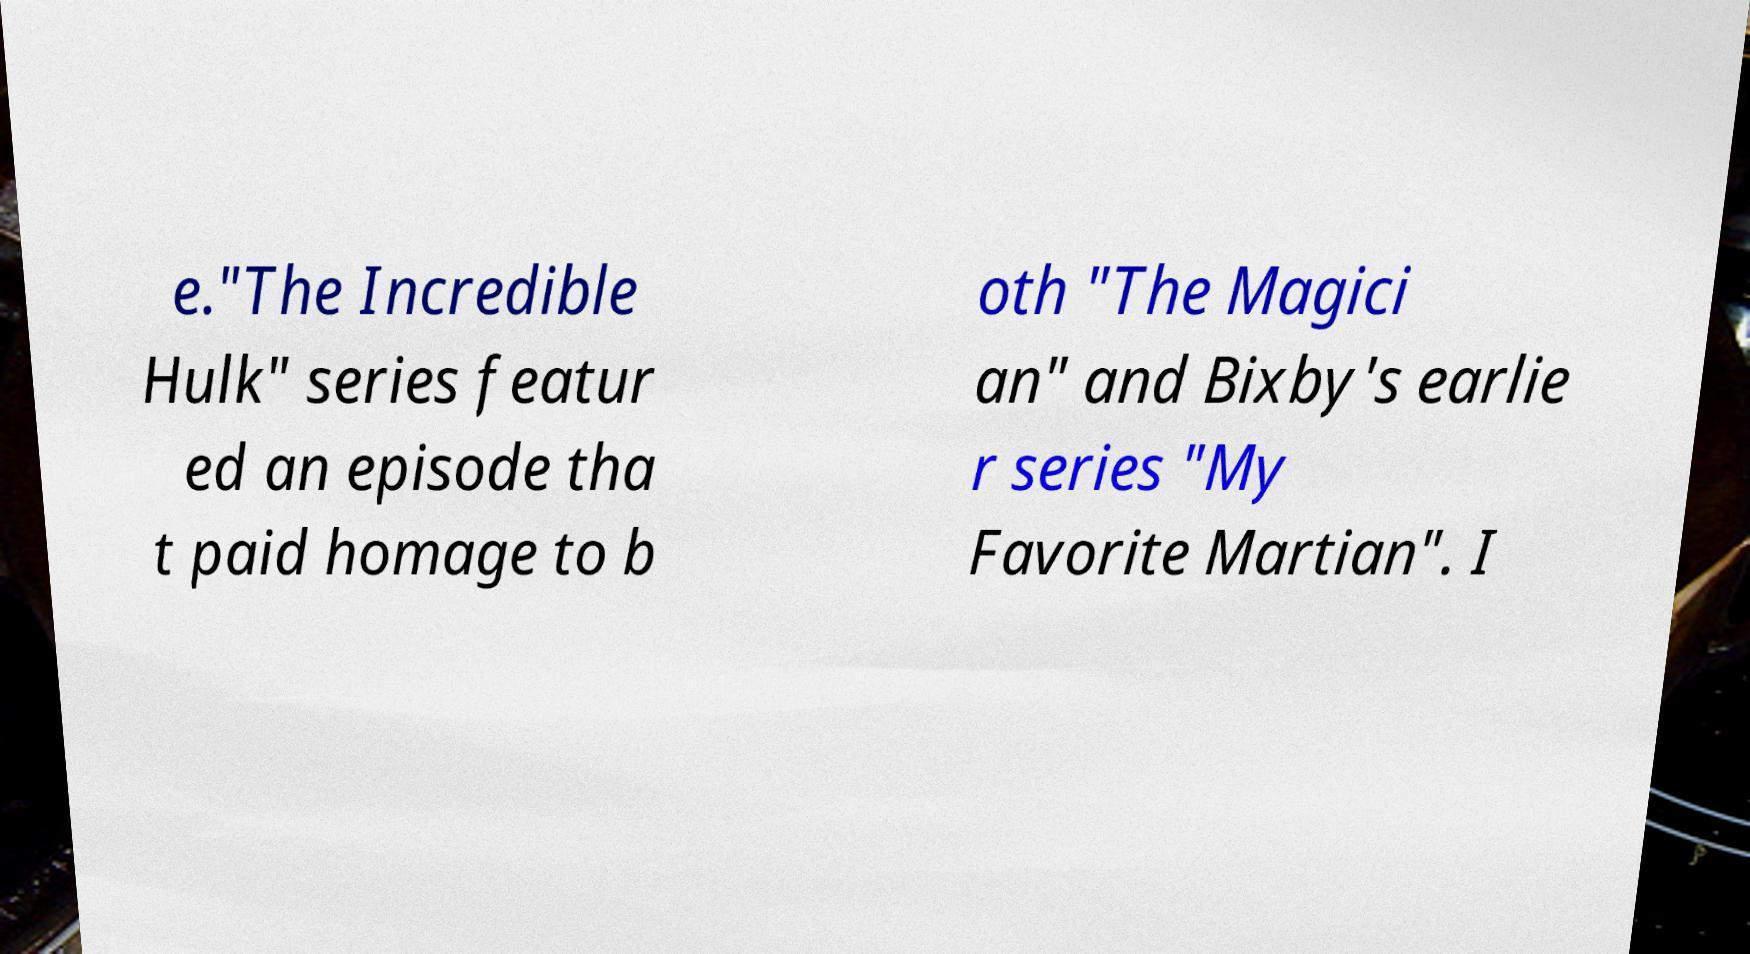Can you read and provide the text displayed in the image?This photo seems to have some interesting text. Can you extract and type it out for me? e."The Incredible Hulk" series featur ed an episode tha t paid homage to b oth "The Magici an" and Bixby's earlie r series "My Favorite Martian". I 